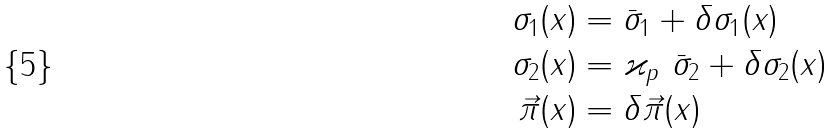Convert formula to latex. <formula><loc_0><loc_0><loc_500><loc_500>\sigma _ { 1 } ( x ) & = \bar { \sigma } _ { 1 } + \delta \sigma _ { 1 } ( x ) \\ \sigma _ { 2 } ( x ) & = \varkappa _ { p } \ \bar { \sigma } _ { 2 } + \delta \sigma _ { 2 } ( x ) \\ \vec { \pi } ( x ) & = \delta \vec { \pi } ( x )</formula> 